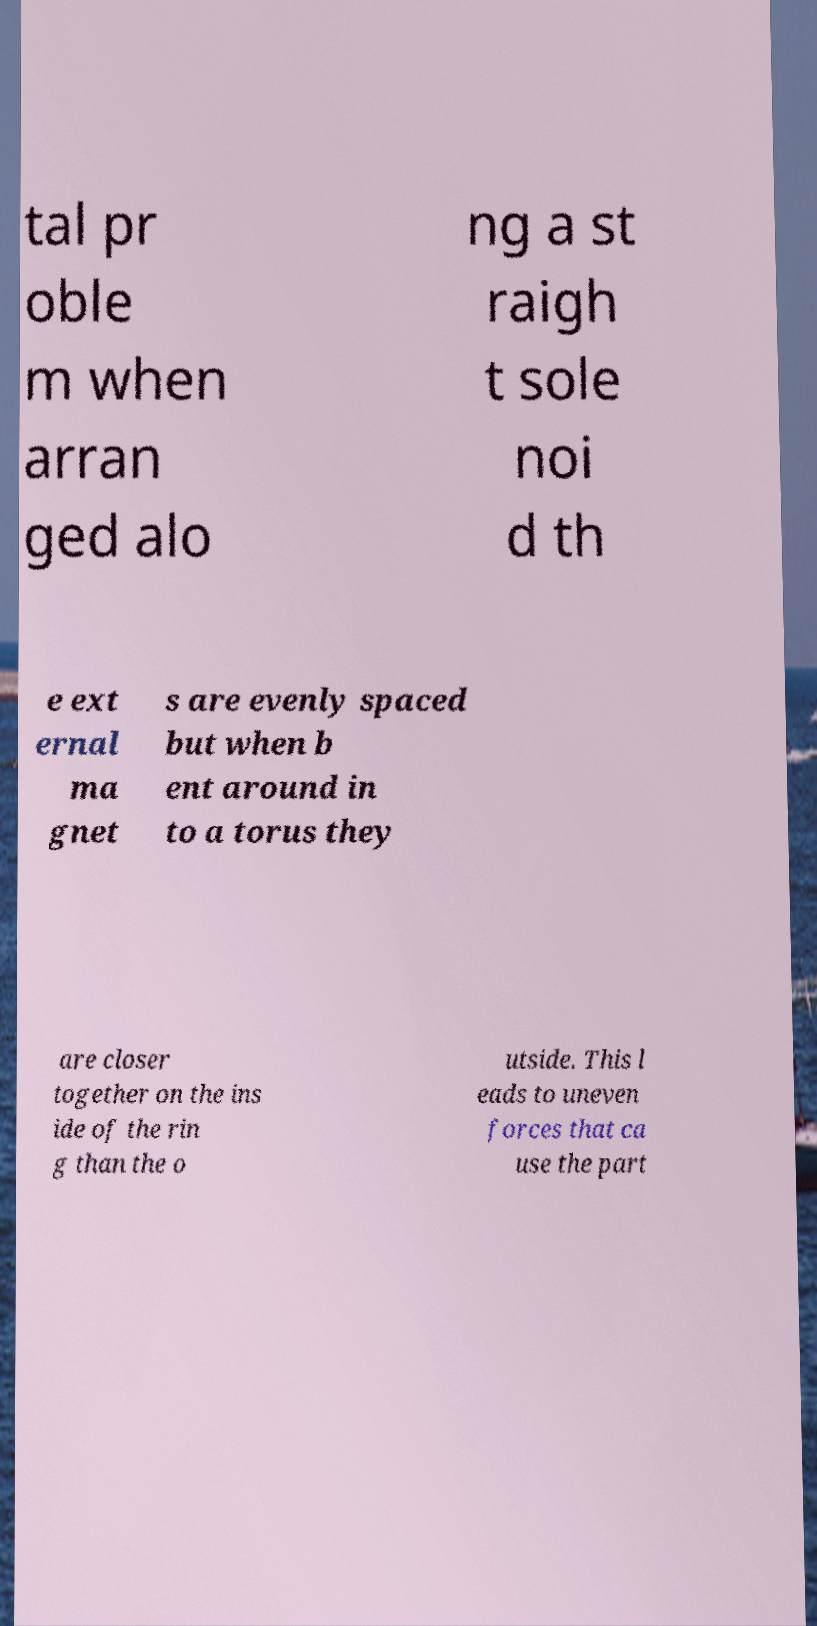Can you accurately transcribe the text from the provided image for me? tal pr oble m when arran ged alo ng a st raigh t sole noi d th e ext ernal ma gnet s are evenly spaced but when b ent around in to a torus they are closer together on the ins ide of the rin g than the o utside. This l eads to uneven forces that ca use the part 